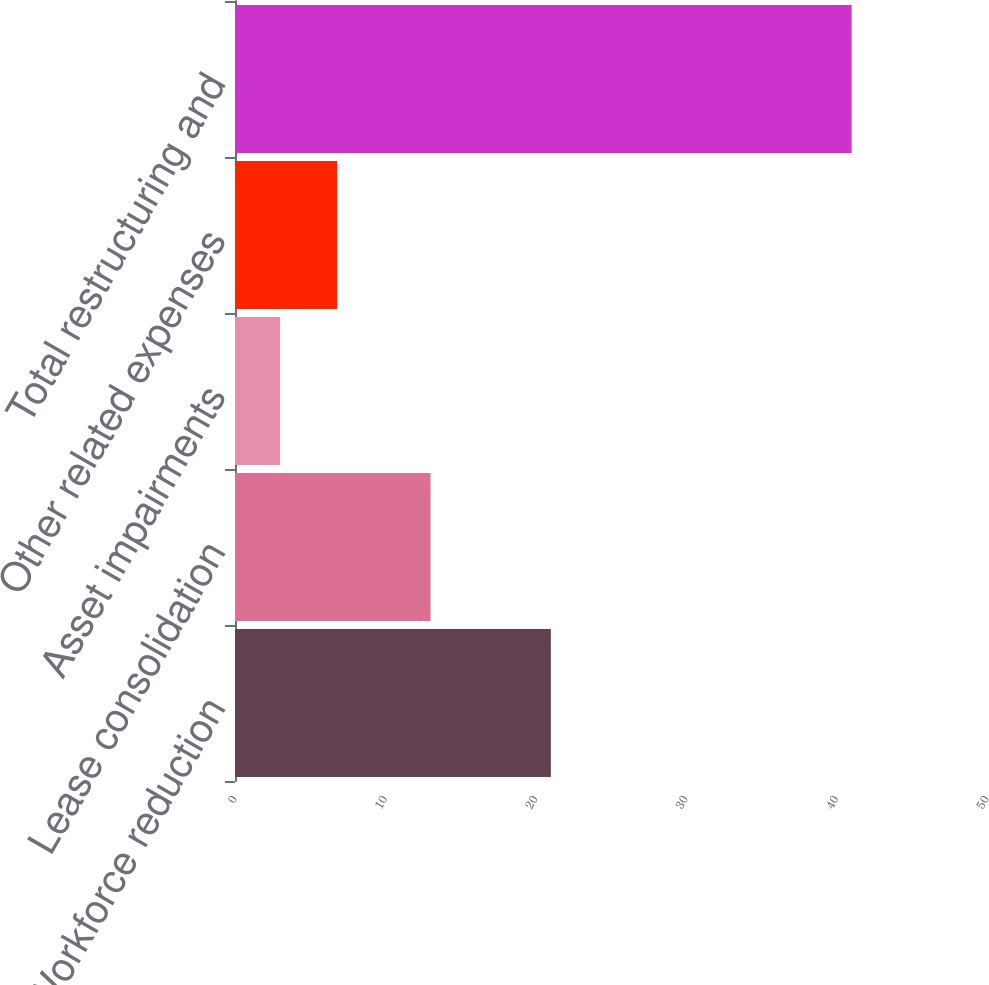Convert chart to OTSL. <chart><loc_0><loc_0><loc_500><loc_500><bar_chart><fcel>Workforce reduction<fcel>Lease consolidation<fcel>Asset impairments<fcel>Other related expenses<fcel>Total restructuring and<nl><fcel>21<fcel>13<fcel>3<fcel>6.8<fcel>41<nl></chart> 